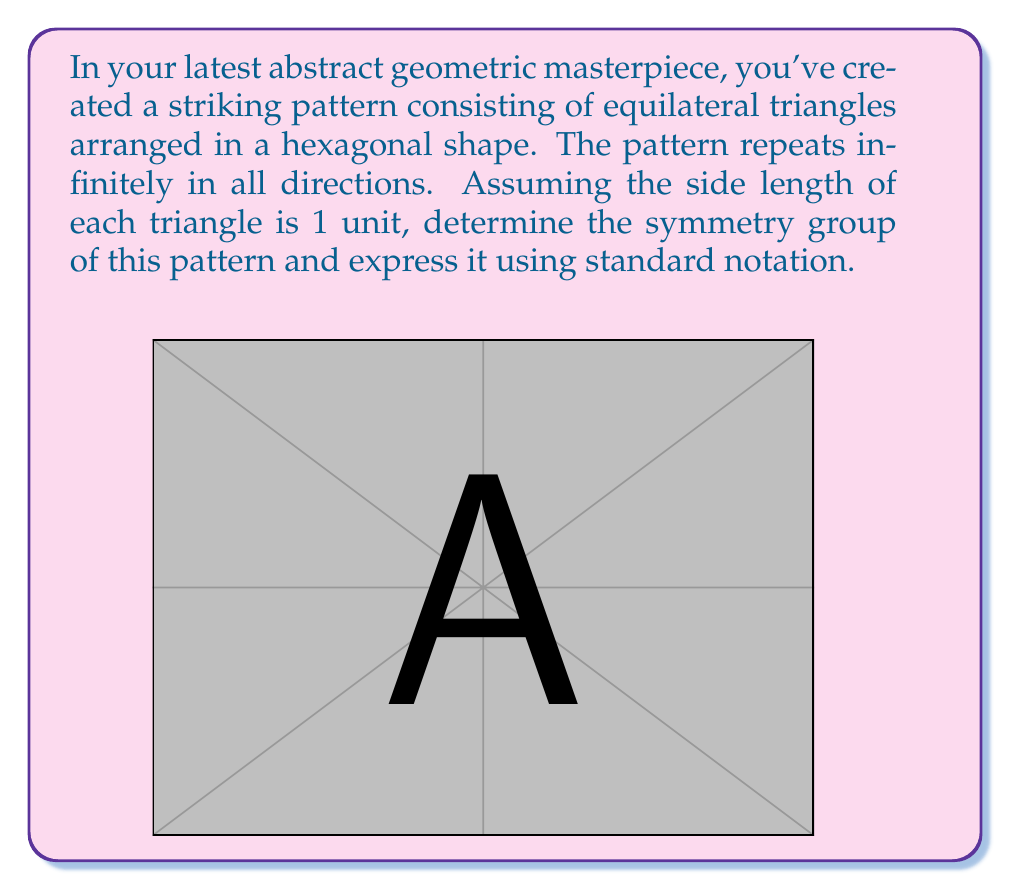What is the answer to this math problem? To determine the symmetry group of this pattern, we need to identify all the symmetry operations that leave the pattern unchanged. Let's proceed step-by-step:

1) Rotational symmetry:
   - The pattern has 6-fold rotational symmetry around the center of each hexagon.
   - It also has 3-fold rotational symmetry around the center of each triangle.
   - There's 2-fold rotational symmetry (180° rotation) around the midpoint of each triangle's edge.

2) Reflection symmetry:
   - There are reflection lines through the center of each hexagon, bisecting opposite sides.
   - There are also reflection lines through the vertices of the hexagons.

3) Translational symmetry:
   - The pattern repeats infinitely in all directions, so there's translational symmetry.

4) Glide reflection:
   - The pattern also exhibits glide reflection symmetry.

These symmetries correspond to the wallpaper group p6m, which is one of the 17 two-dimensional crystallographic groups.

The notation p6m can be broken down as follows:
- p: primitive cell (the simplest repeating unit)
- 6: highest order of rotational symmetry (6-fold)
- m: reflection symmetry

This group includes:
- 6-fold, 3-fold, and 2-fold rotations
- Reflections in 6 distinct directions
- Translations
- Glide reflections

The order of this group is infinite due to the translational symmetry.
Answer: p6m 